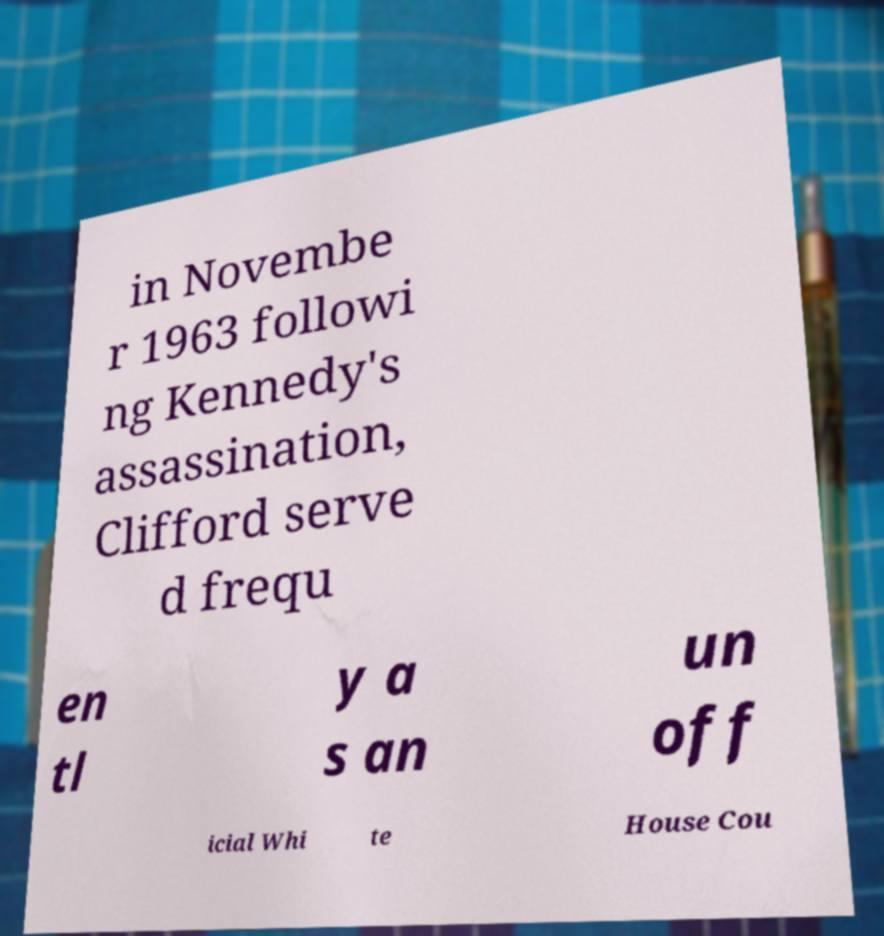Could you assist in decoding the text presented in this image and type it out clearly? in Novembe r 1963 followi ng Kennedy's assassination, Clifford serve d frequ en tl y a s an un off icial Whi te House Cou 